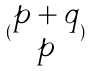Convert formula to latex. <formula><loc_0><loc_0><loc_500><loc_500>( \begin{matrix} p + q \\ p \end{matrix} )</formula> 